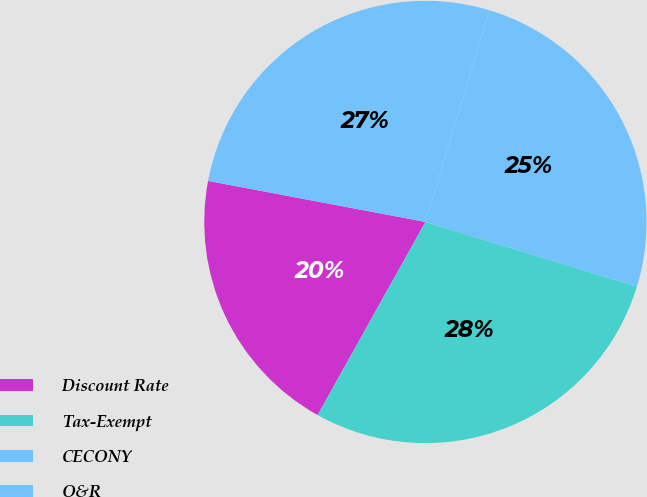<chart> <loc_0><loc_0><loc_500><loc_500><pie_chart><fcel>Discount Rate<fcel>Tax-Exempt<fcel>CECONY<fcel>O&R<nl><fcel>19.87%<fcel>28.38%<fcel>25.04%<fcel>26.71%<nl></chart> 